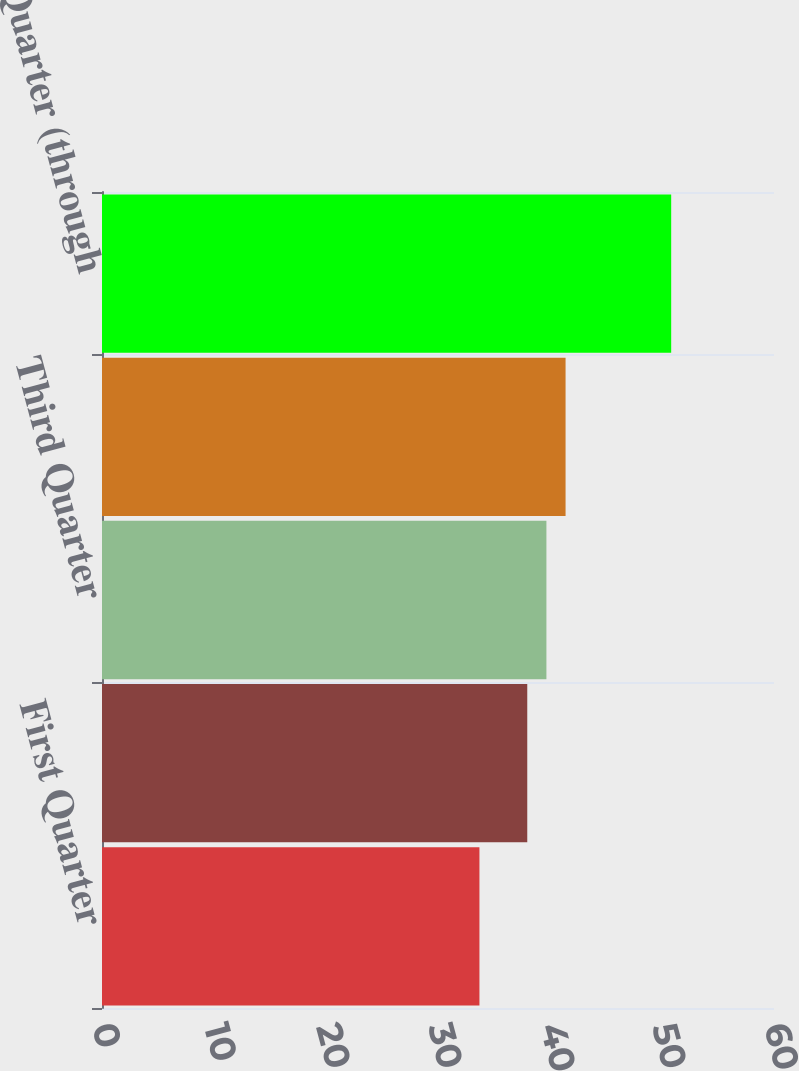Convert chart to OTSL. <chart><loc_0><loc_0><loc_500><loc_500><bar_chart><fcel>First Quarter<fcel>Second Quarter<fcel>Third Quarter<fcel>Fourth Quarter<fcel>First Quarter (through<nl><fcel>33.7<fcel>37.97<fcel>39.68<fcel>41.39<fcel>50.82<nl></chart> 